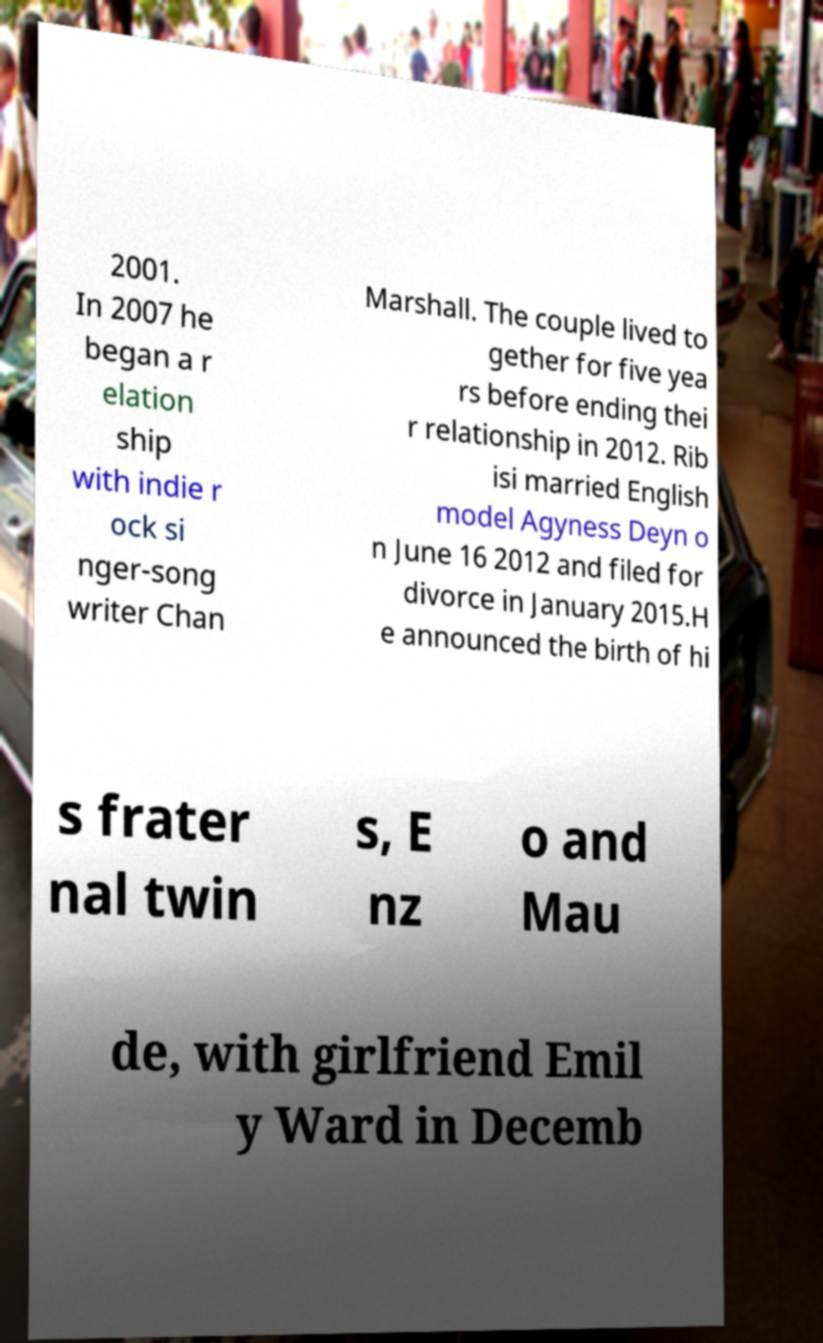Could you extract and type out the text from this image? 2001. In 2007 he began a r elation ship with indie r ock si nger-song writer Chan Marshall. The couple lived to gether for five yea rs before ending thei r relationship in 2012. Rib isi married English model Agyness Deyn o n June 16 2012 and filed for divorce in January 2015.H e announced the birth of hi s frater nal twin s, E nz o and Mau de, with girlfriend Emil y Ward in Decemb 